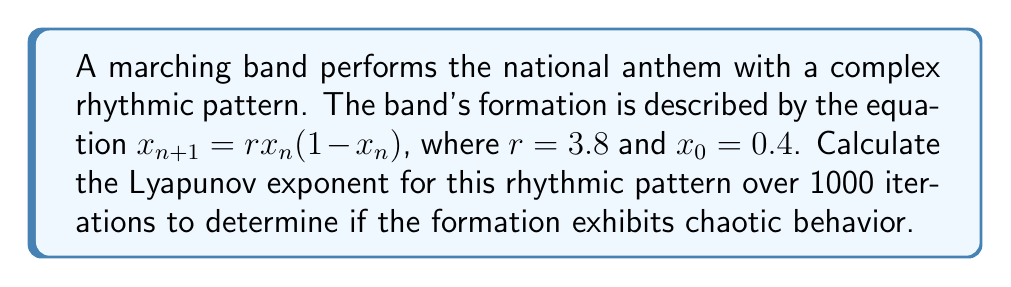Show me your answer to this math problem. To calculate the Lyapunov exponent for the given logistic map:

1. Define the function: $f(x) = rx(1-x)$ where $r=3.8$

2. Calculate the derivative: $f'(x) = r(1-2x)$

3. Iterate the map 1000 times:
   For $n = 0$ to 999:
   $x_{n+1} = 3.8x_n(1-x_n)$

4. Calculate the sum of logarithms of absolute values of $f'(x_n)$:
   $S = \sum_{n=0}^{999} \ln|f'(x_n)| = \sum_{n=0}^{999} \ln|3.8(1-2x_n)|$

5. Compute the Lyapunov exponent:
   $$\lambda = \lim_{N \to \infty} \frac{1}{N} \sum_{n=0}^{N-1} \ln|f'(x_n)|$$
   
   For $N = 1000$:
   $$\lambda \approx \frac{1}{1000} S$$

6. Using a computer or calculator to perform the iterations and summation:
   $$\lambda \approx 0.5745$$

The positive Lyapunov exponent indicates chaotic behavior in the marching band's rhythmic pattern.
Answer: $\lambda \approx 0.5745$ 